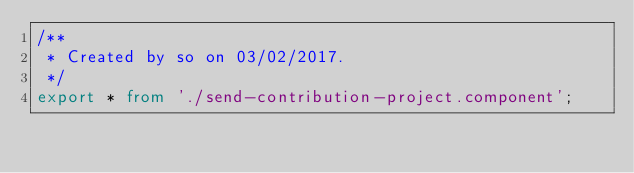<code> <loc_0><loc_0><loc_500><loc_500><_TypeScript_>/**
 * Created by so on 03/02/2017.
 */
export * from './send-contribution-project.component';
</code> 